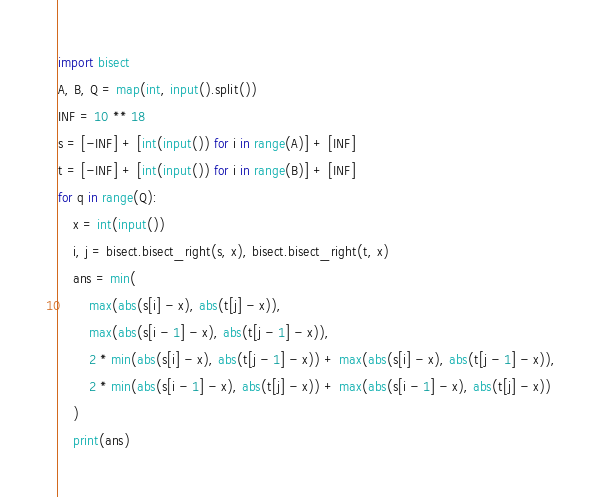<code> <loc_0><loc_0><loc_500><loc_500><_Python_>import bisect
A, B, Q = map(int, input().split())
INF = 10 ** 18
s = [-INF] + [int(input()) for i in range(A)] + [INF]
t = [-INF] + [int(input()) for i in range(B)] + [INF]
for q in range(Q):
    x = int(input())
    i, j = bisect.bisect_right(s, x), bisect.bisect_right(t, x)
    ans = min(
        max(abs(s[i] - x), abs(t[j] - x)),
        max(abs(s[i - 1] - x), abs(t[j - 1] - x)),
        2 * min(abs(s[i] - x), abs(t[j - 1] - x)) + max(abs(s[i] - x), abs(t[j - 1] - x)),
        2 * min(abs(s[i - 1] - x), abs(t[j] - x)) + max(abs(s[i - 1] - x), abs(t[j] - x))
    )
    print(ans)
</code> 